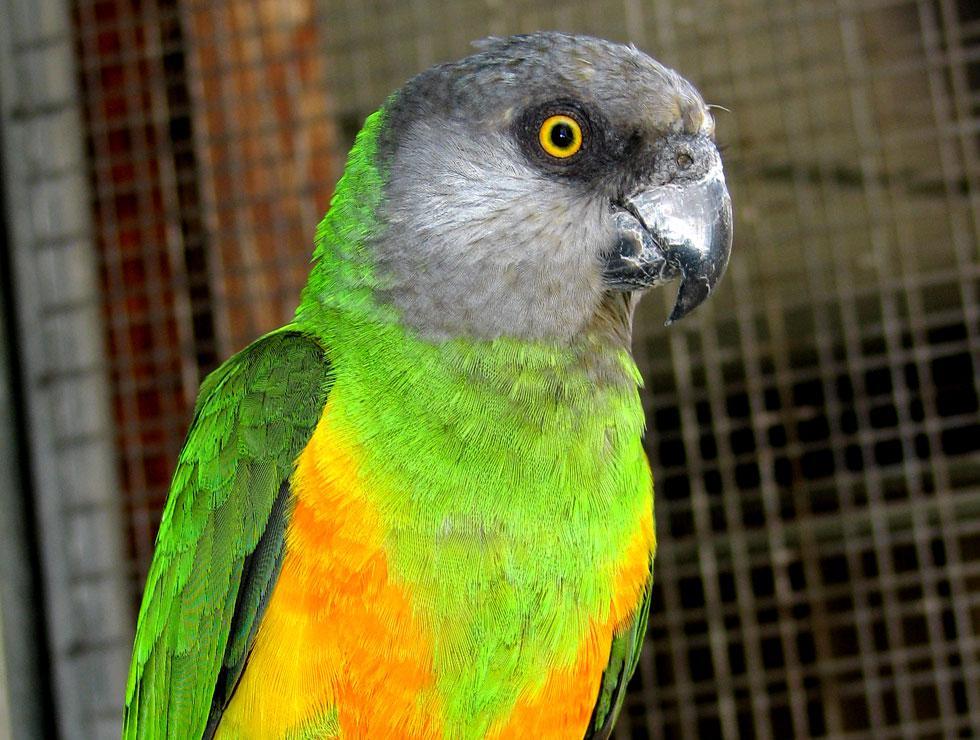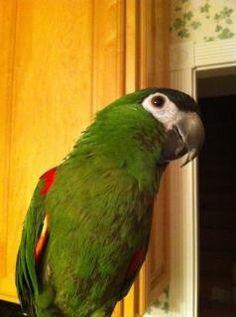The first image is the image on the left, the second image is the image on the right. Evaluate the accuracy of this statement regarding the images: "There are two parrots in total, both with predominantly green feathers.". Is it true? Answer yes or no. Yes. The first image is the image on the left, the second image is the image on the right. Given the left and right images, does the statement "An image contains one right-facing parrot in front of a mesh." hold true? Answer yes or no. Yes. 